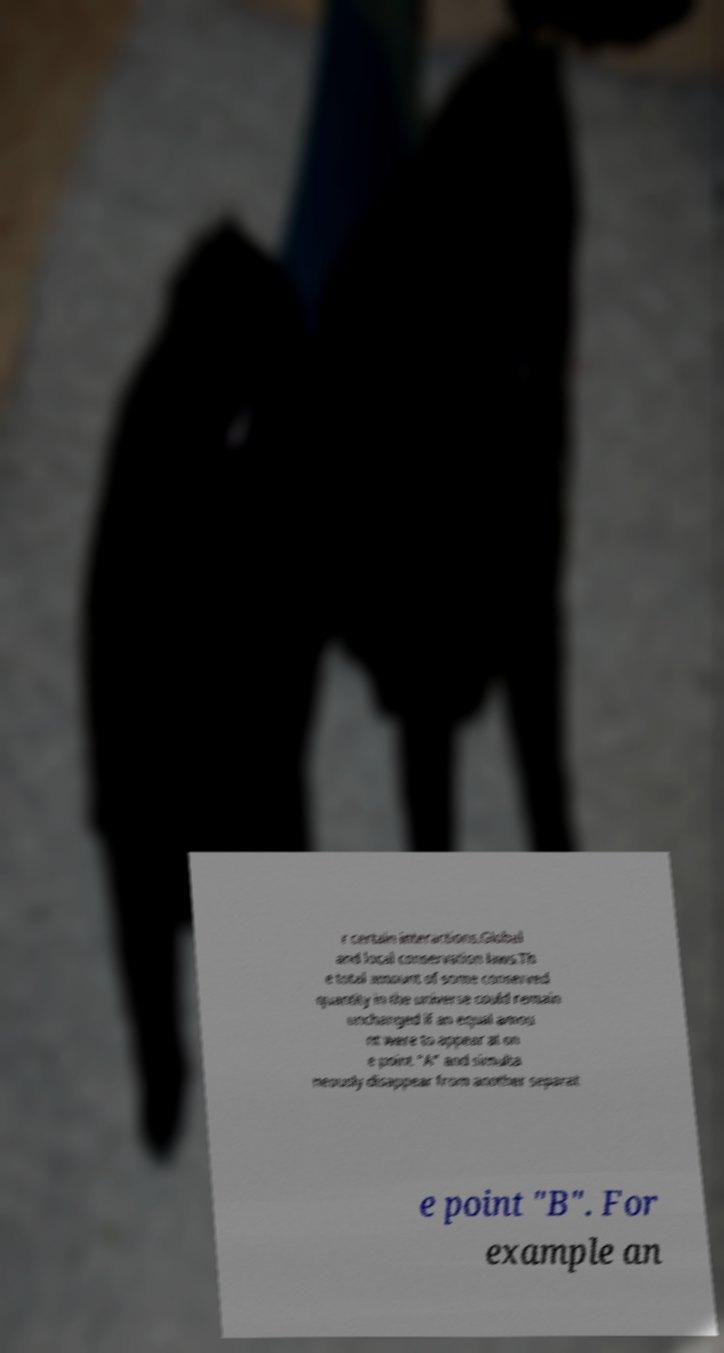Please identify and transcribe the text found in this image. r certain interactions.Global and local conservation laws.Th e total amount of some conserved quantity in the universe could remain unchanged if an equal amou nt were to appear at on e point "A" and simulta neously disappear from another separat e point "B". For example an 